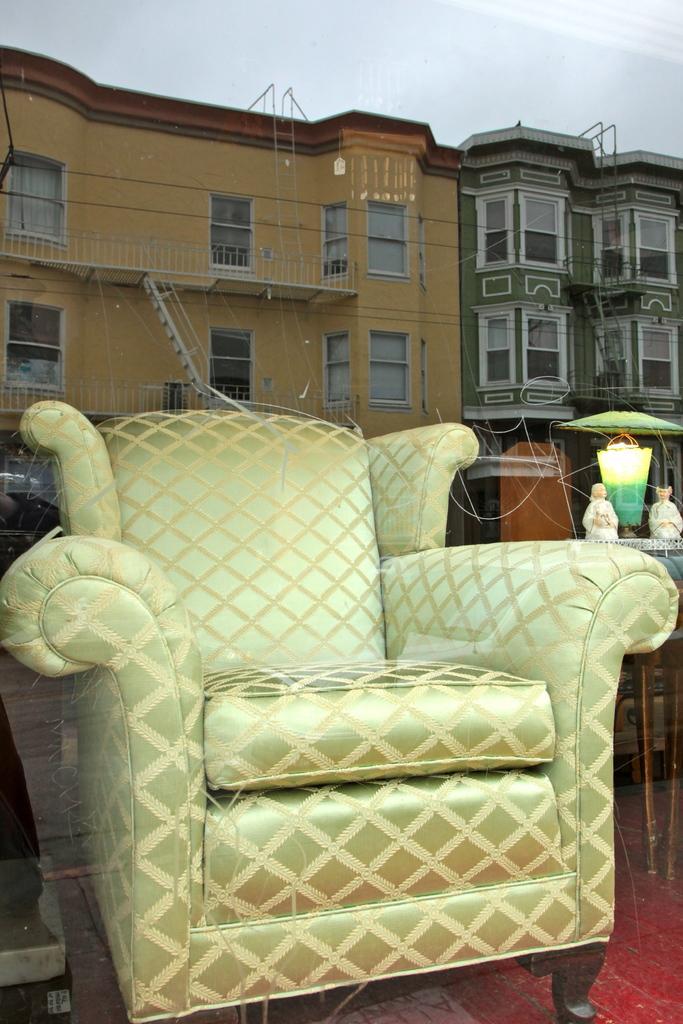How would you summarize this image in a sentence or two? In this picture there is a sofa and lamp beside the sofa, there is a reflection of building and other building, and the sky is clear 